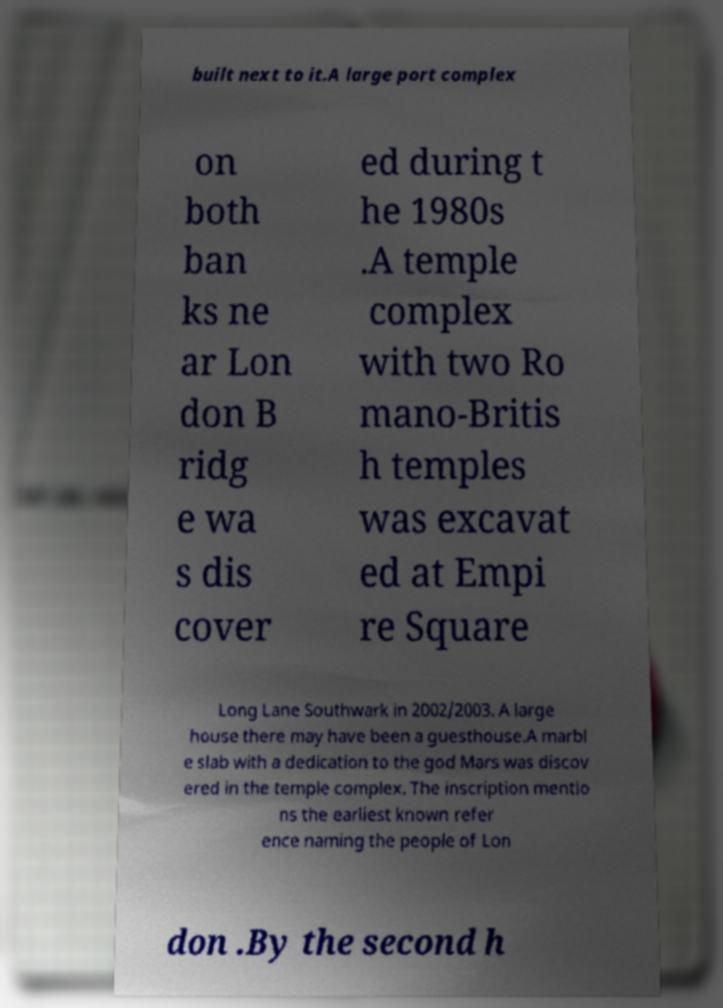Can you accurately transcribe the text from the provided image for me? built next to it.A large port complex on both ban ks ne ar Lon don B ridg e wa s dis cover ed during t he 1980s .A temple complex with two Ro mano-Britis h temples was excavat ed at Empi re Square Long Lane Southwark in 2002/2003. A large house there may have been a guesthouse.A marbl e slab with a dedication to the god Mars was discov ered in the temple complex. The inscription mentio ns the earliest known refer ence naming the people of Lon don .By the second h 